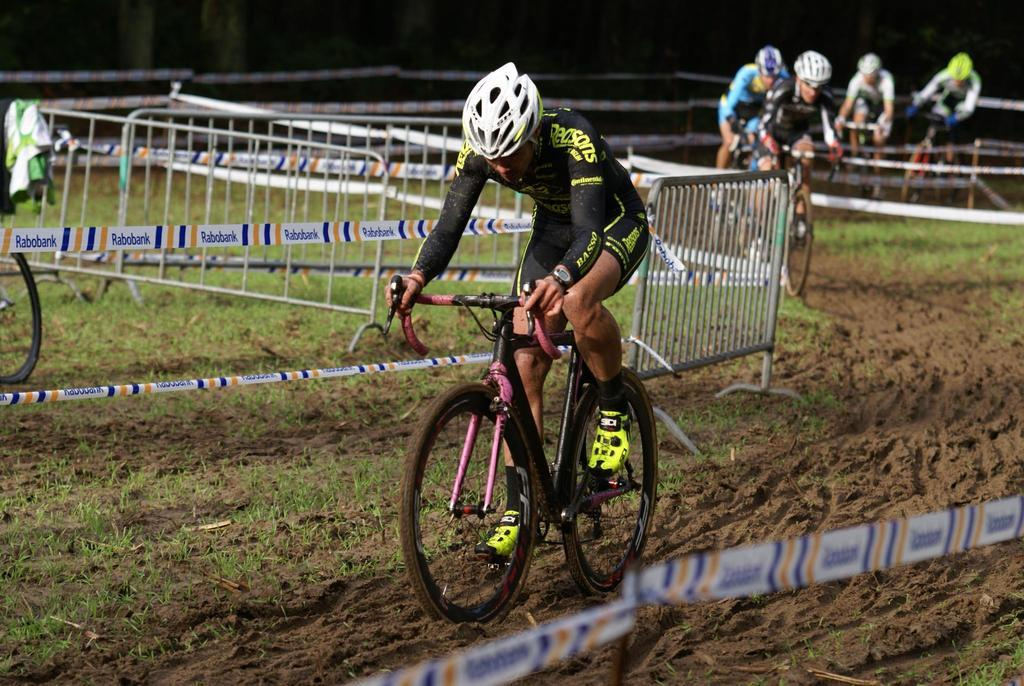What are the people in the image doing? The people in the image are cycling. What safety precaution are the cyclists taking? The people are wearing helmets. What can be seen in the background of the image? There is metal fencing in the image. What additional items can be seen in the image? There are ribbons in the image. What type of ground is visible at the bottom of the image? There is soil and grass at the bottom of the image. What type of mist is covering the cyclists in the image? There is no mist present in the image; the cyclists are not covered by any mist. What type of property is visible in the image? The image does not show any specific property or building; it primarily features cyclists and their surroundings. 